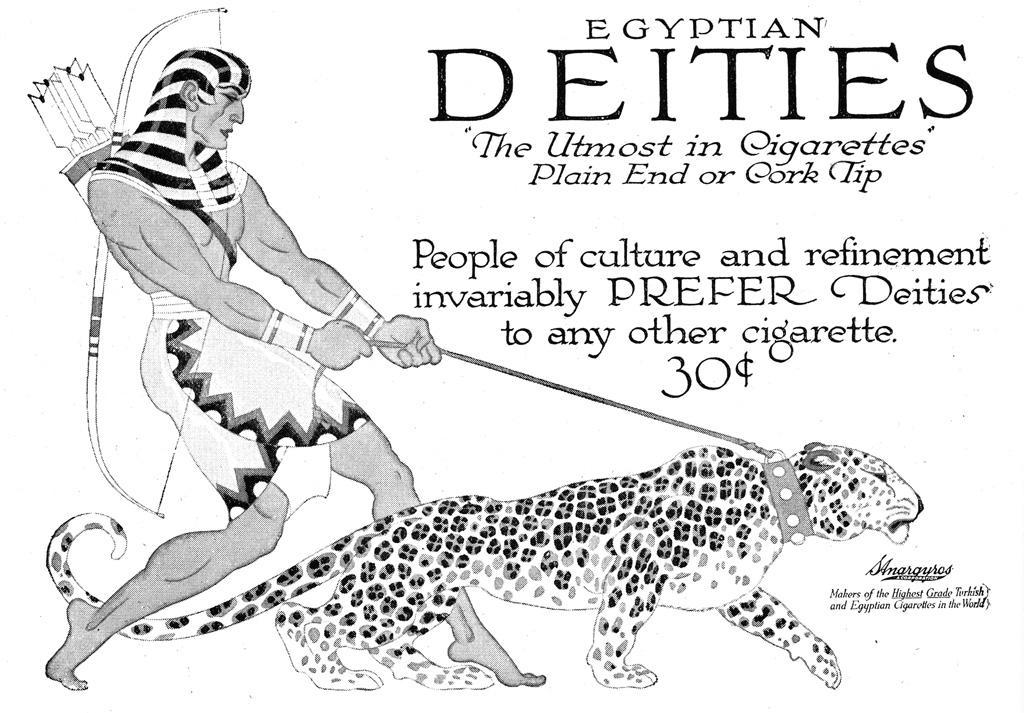What is the main subject of the image? There is an advertisement in the image. Can you describe the advertisement? Unfortunately, the provided facts do not include any details about the advertisement. However, we can confirm that it is the main subject of the image. What type of pie is being served in the afternoon in the image? There is no pie or afternoon setting present in the image; it only features an advertisement. 